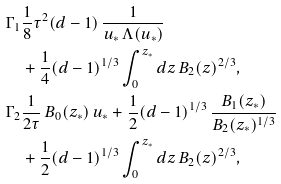Convert formula to latex. <formula><loc_0><loc_0><loc_500><loc_500>\Gamma _ { 1 } & \frac { 1 } { 8 } \tau ^ { 2 } ( d - 1 ) \, \frac { 1 } { u _ { * } \, \Lambda ( u _ { * } ) } \\ & + \frac { 1 } { 4 } ( d - 1 ) ^ { 1 / 3 } \int _ { 0 } ^ { z _ { * } } d z \, B _ { 2 } ( z ) ^ { 2 / 3 } , \\ \Gamma _ { 2 } & \frac { 1 } { 2 \tau } \, B _ { 0 } ( z _ { * } ) \, u _ { * } + \frac { 1 } { 2 } ( d - 1 ) ^ { 1 / 3 } \, \frac { B _ { 1 } ( z _ { * } ) } { B _ { 2 } ( z _ { * } ) ^ { 1 / 3 } } \\ & + \frac { 1 } { 2 } ( d - 1 ) ^ { 1 / 3 } \int _ { 0 } ^ { z _ { * } } d z \, B _ { 2 } ( z ) ^ { 2 / 3 } ,</formula> 